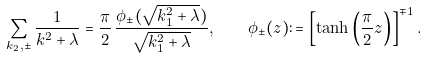<formula> <loc_0><loc_0><loc_500><loc_500>\sum _ { k _ { 2 } , \pm } \frac { 1 } { k ^ { 2 } + \lambda } = \frac { \pi } { 2 } \, \frac { \phi _ { \pm } ( \sqrt { k _ { 1 } ^ { 2 } + \lambda } ) } { \sqrt { k _ { 1 } ^ { 2 } + \lambda } } , \quad \phi _ { \pm } ( z ) \colon = \left [ \tanh \left ( \frac { \pi } 2 z \right ) \right ] ^ { \mp 1 } .</formula> 